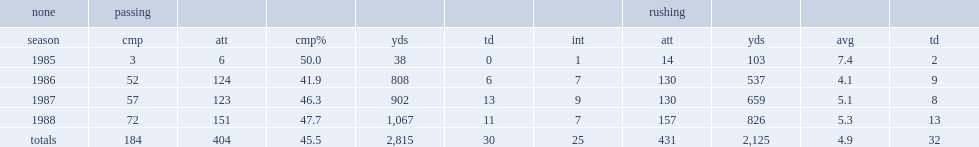How many rushing yards did steve taylor get in 1988? 826.0. 